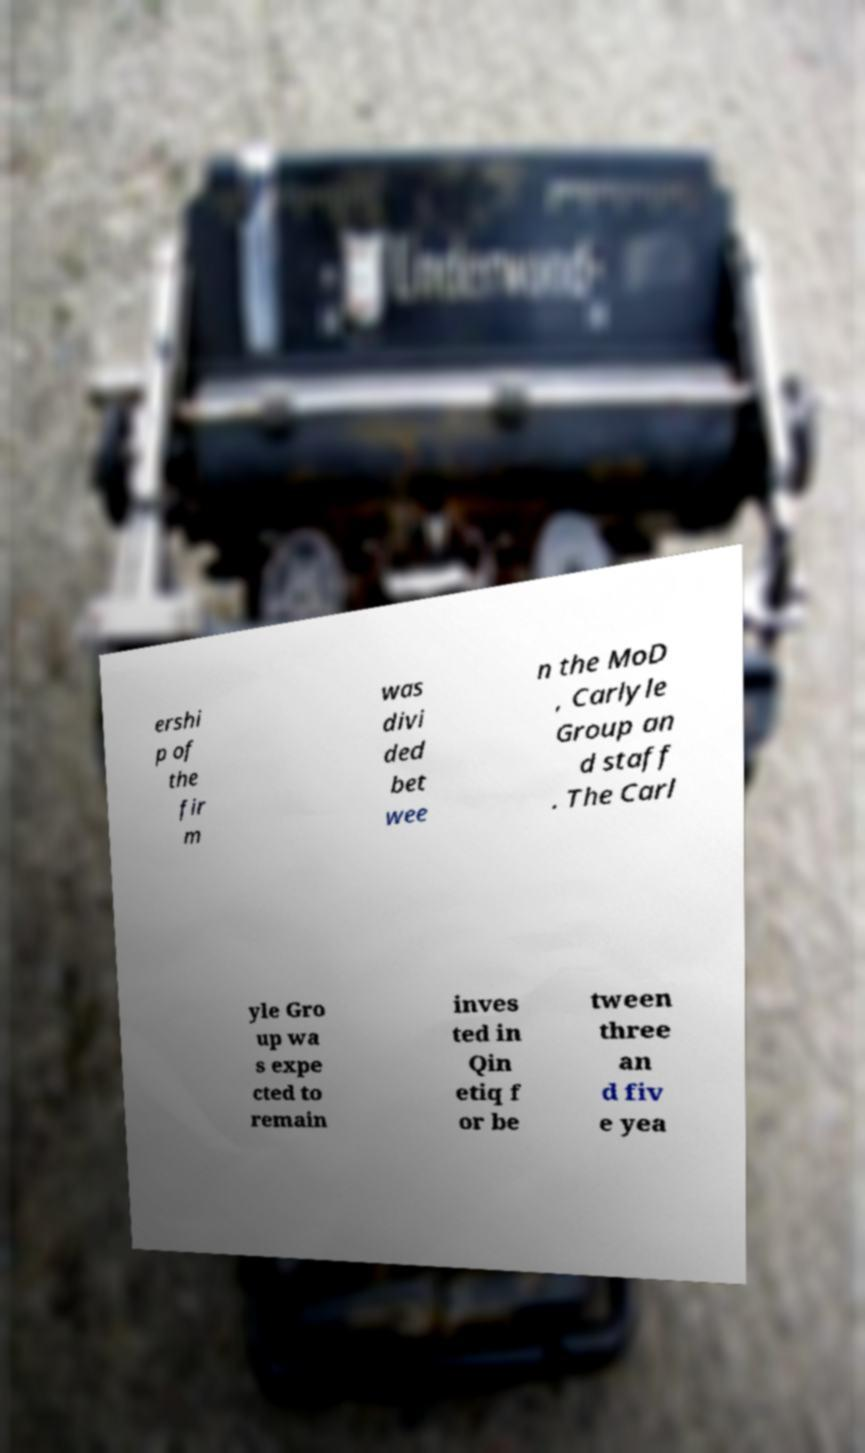Please read and relay the text visible in this image. What does it say? ershi p of the fir m was divi ded bet wee n the MoD , Carlyle Group an d staff . The Carl yle Gro up wa s expe cted to remain inves ted in Qin etiq f or be tween three an d fiv e yea 